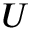<formula> <loc_0><loc_0><loc_500><loc_500>U</formula> 